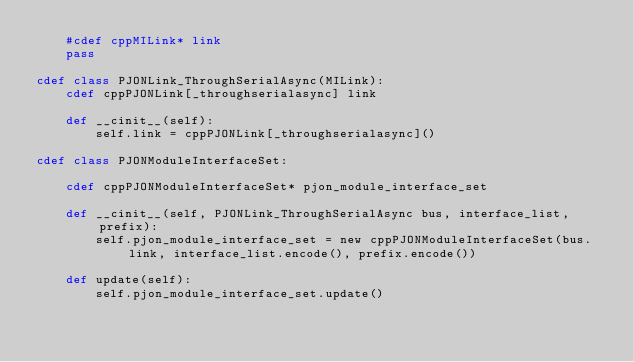Convert code to text. <code><loc_0><loc_0><loc_500><loc_500><_Cython_>    #cdef cppMILink* link
    pass

cdef class PJONLink_ThroughSerialAsync(MILink):
    cdef cppPJONLink[_throughserialasync] link

    def __cinit__(self):
        self.link = cppPJONLink[_throughserialasync]()

cdef class PJONModuleInterfaceSet:

    cdef cppPJONModuleInterfaceSet* pjon_module_interface_set

    def __cinit__(self, PJONLink_ThroughSerialAsync bus, interface_list, prefix):
        self.pjon_module_interface_set = new cppPJONModuleInterfaceSet(bus.link, interface_list.encode(), prefix.encode())

    def update(self):
        self.pjon_module_interface_set.update()

</code> 